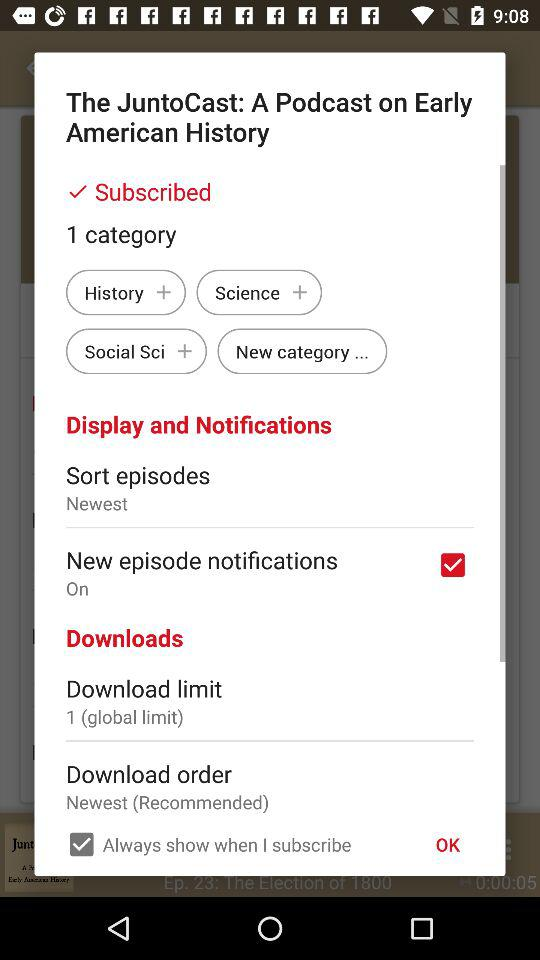What is the status of the "New episode notifications"? The status is "on". 